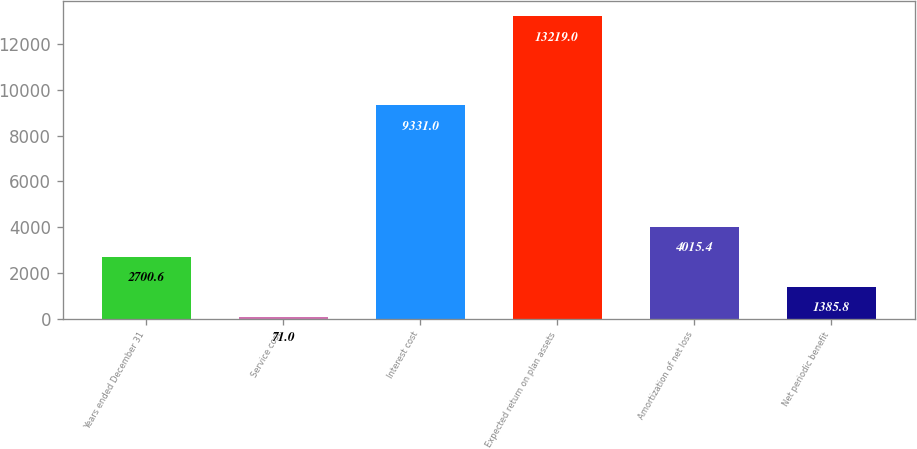Convert chart to OTSL. <chart><loc_0><loc_0><loc_500><loc_500><bar_chart><fcel>Years ended December 31<fcel>Service cost<fcel>Interest cost<fcel>Expected return on plan assets<fcel>Amortization of net loss<fcel>Net periodic benefit<nl><fcel>2700.6<fcel>71<fcel>9331<fcel>13219<fcel>4015.4<fcel>1385.8<nl></chart> 